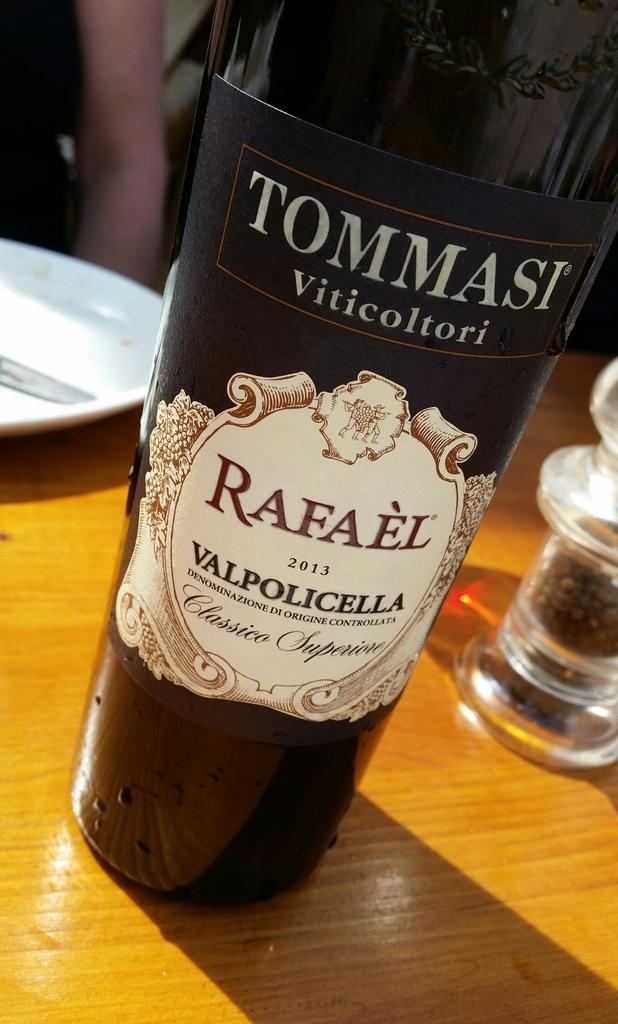Provide a one-sentence caption for the provided image. A wine bottle that says Ommasi Viticoltori on it. 